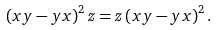Convert formula to latex. <formula><loc_0><loc_0><loc_500><loc_500>\left ( x y - y x \right ) ^ { 2 } z = z \left ( x y - y x \right ) ^ { 2 } .</formula> 